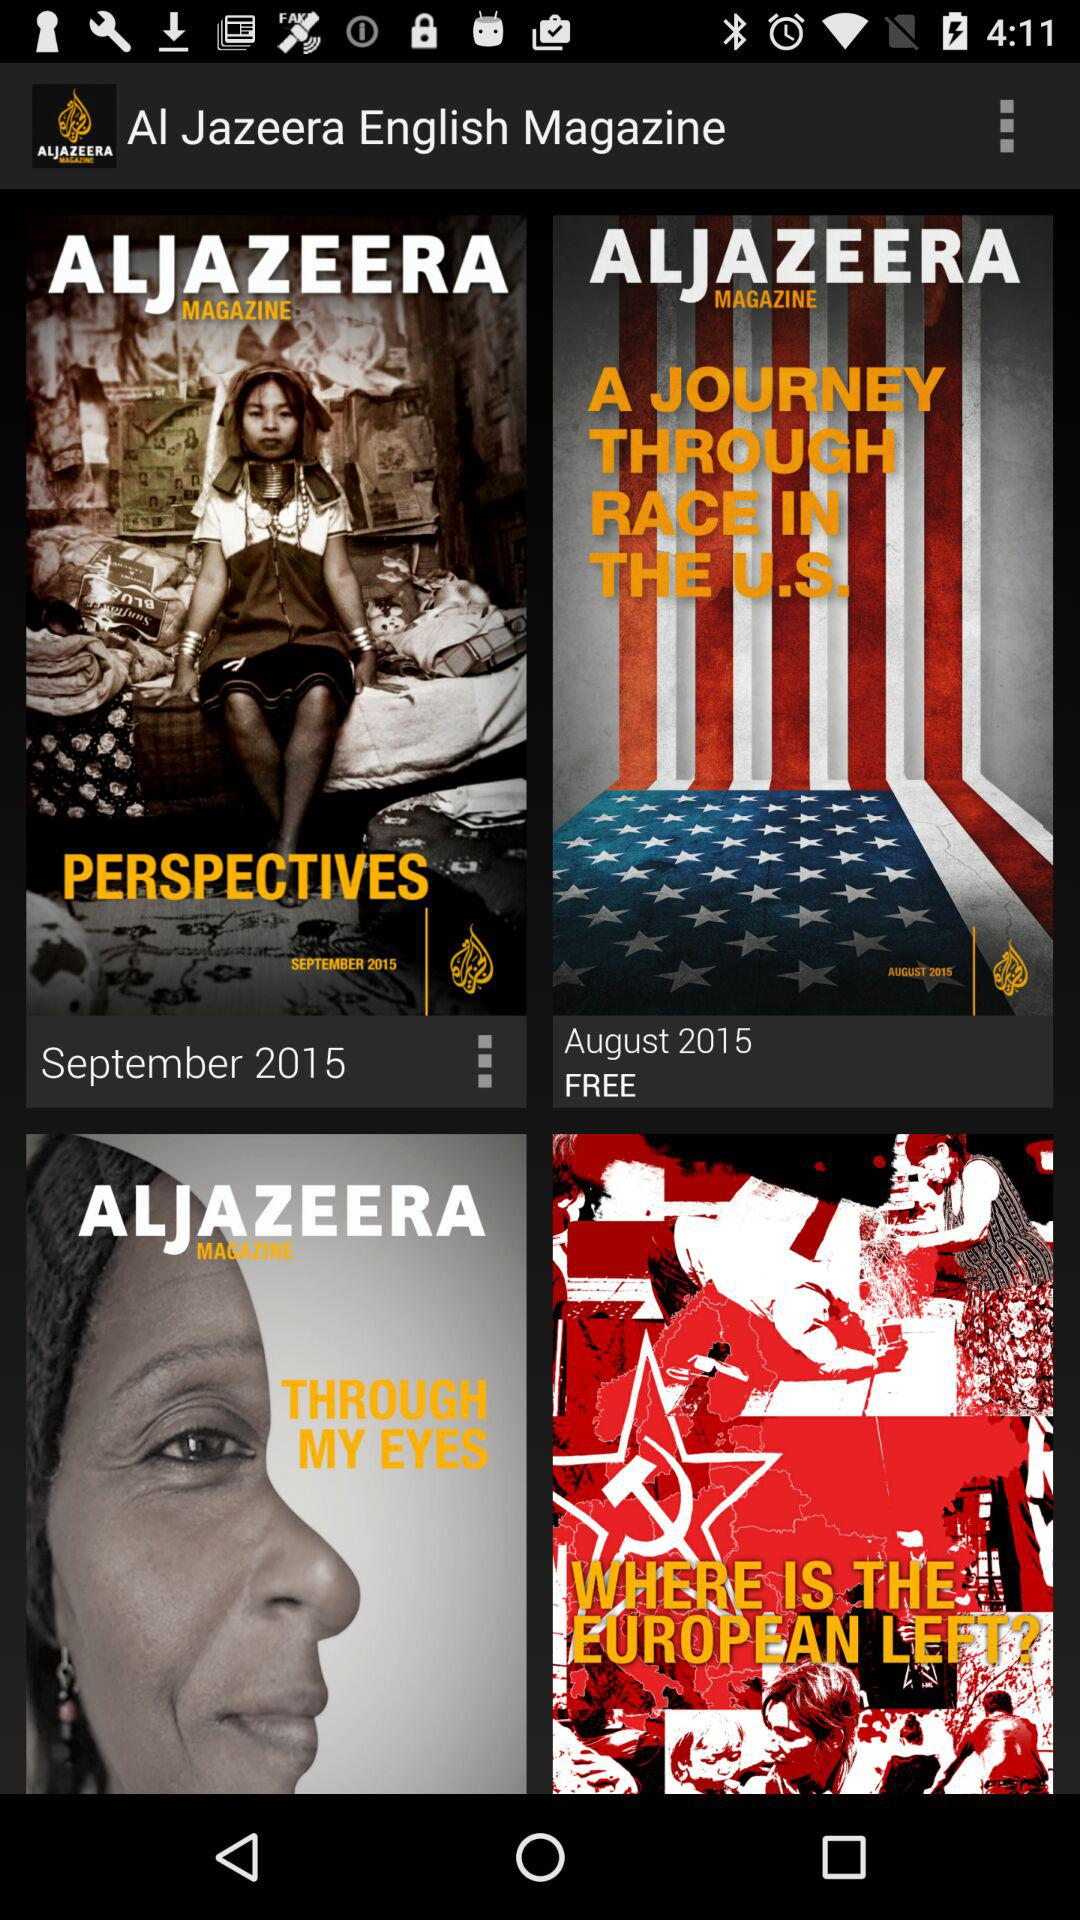What is the cost of the magazine "A JOURNEY THROUGH RACE IN THE U.S."? The magazine is free. 